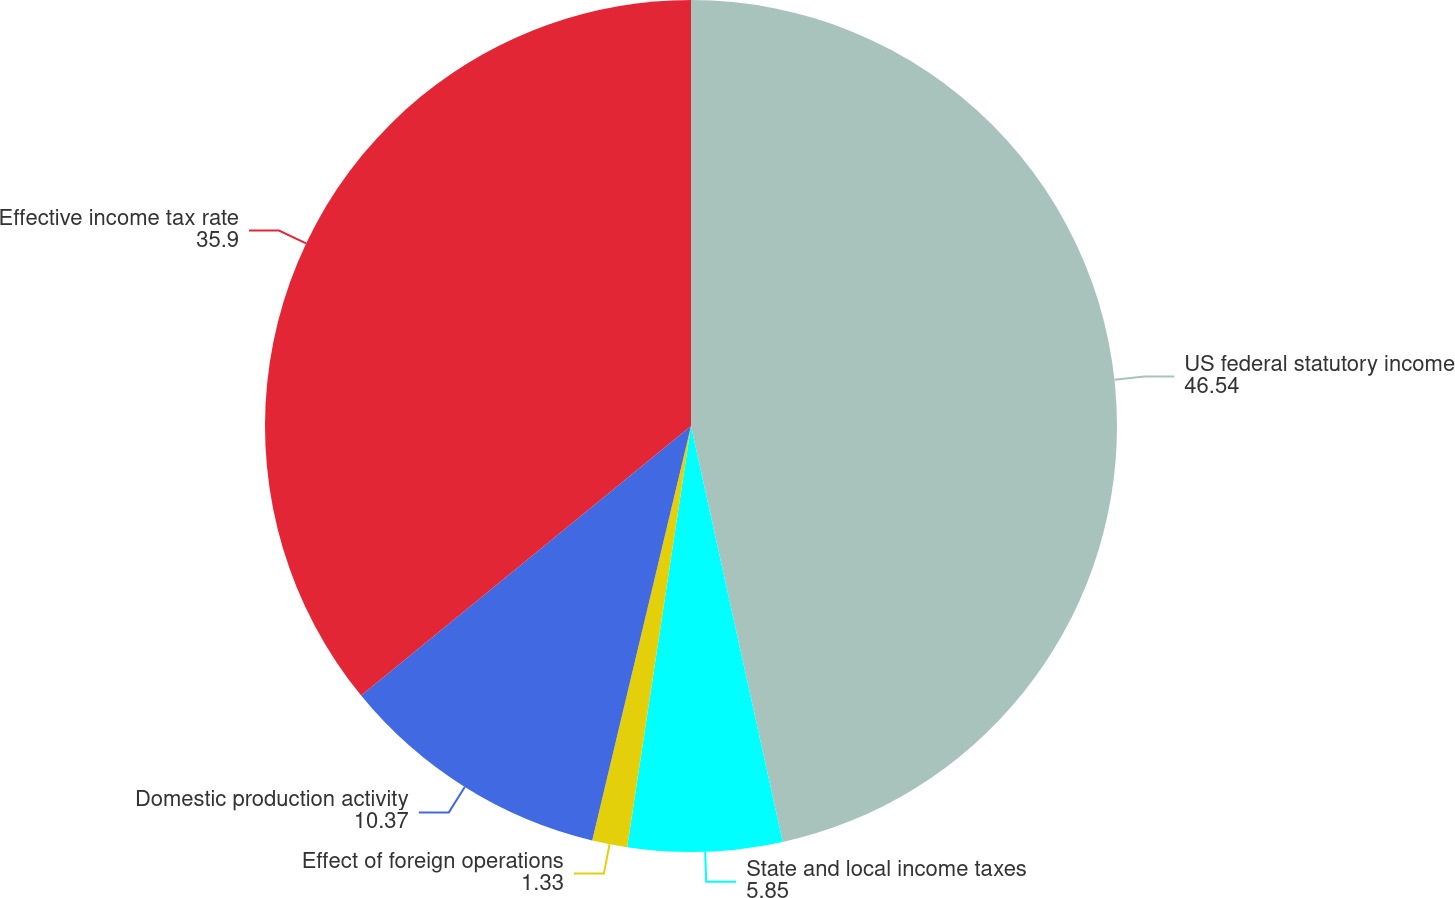Convert chart. <chart><loc_0><loc_0><loc_500><loc_500><pie_chart><fcel>US federal statutory income<fcel>State and local income taxes<fcel>Effect of foreign operations<fcel>Domestic production activity<fcel>Effective income tax rate<nl><fcel>46.54%<fcel>5.85%<fcel>1.33%<fcel>10.37%<fcel>35.9%<nl></chart> 